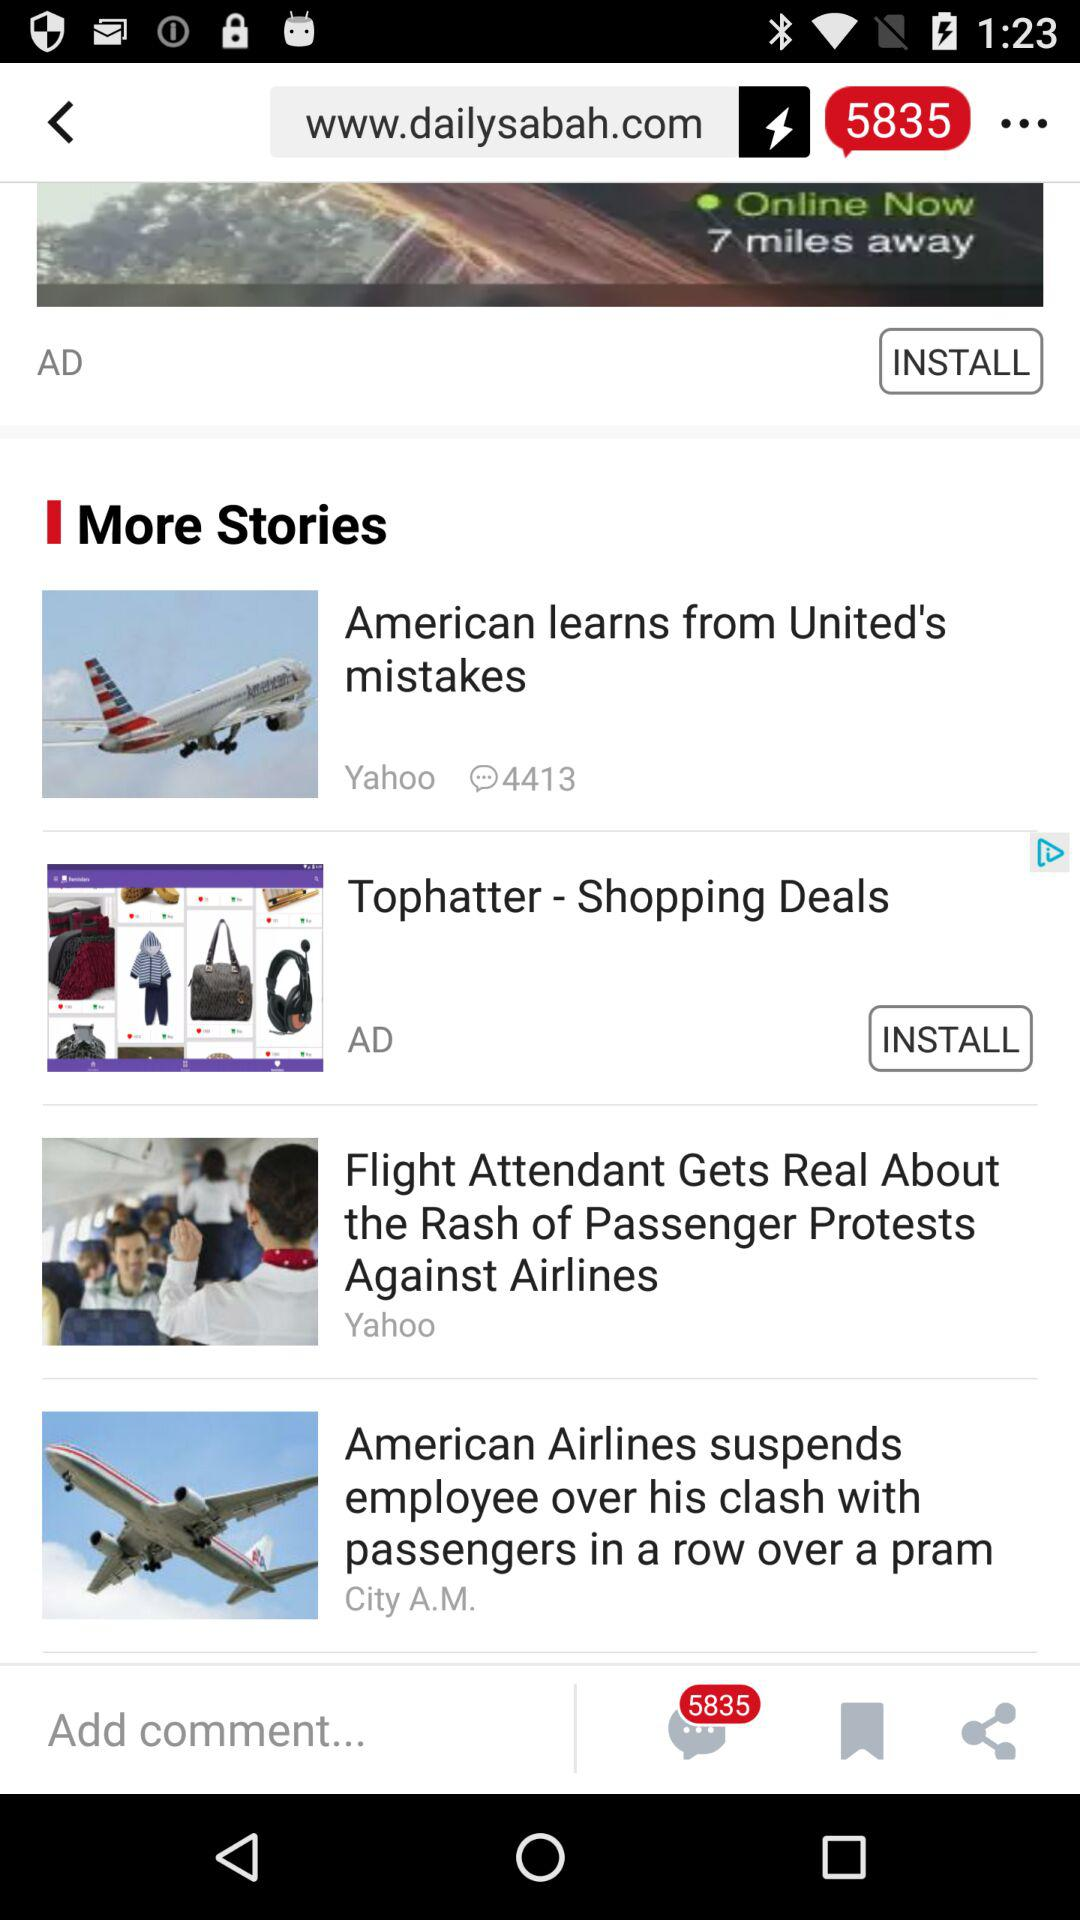How many of the stories are sponsored?
Answer the question using a single word or phrase. 2 